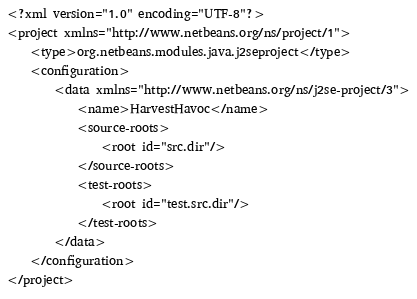Convert code to text. <code><loc_0><loc_0><loc_500><loc_500><_XML_><?xml version="1.0" encoding="UTF-8"?>
<project xmlns="http://www.netbeans.org/ns/project/1">
    <type>org.netbeans.modules.java.j2seproject</type>
    <configuration>
        <data xmlns="http://www.netbeans.org/ns/j2se-project/3">
            <name>HarvestHavoc</name>
            <source-roots>
                <root id="src.dir"/>
            </source-roots>
            <test-roots>
                <root id="test.src.dir"/>
            </test-roots>
        </data>
    </configuration>
</project>
</code> 